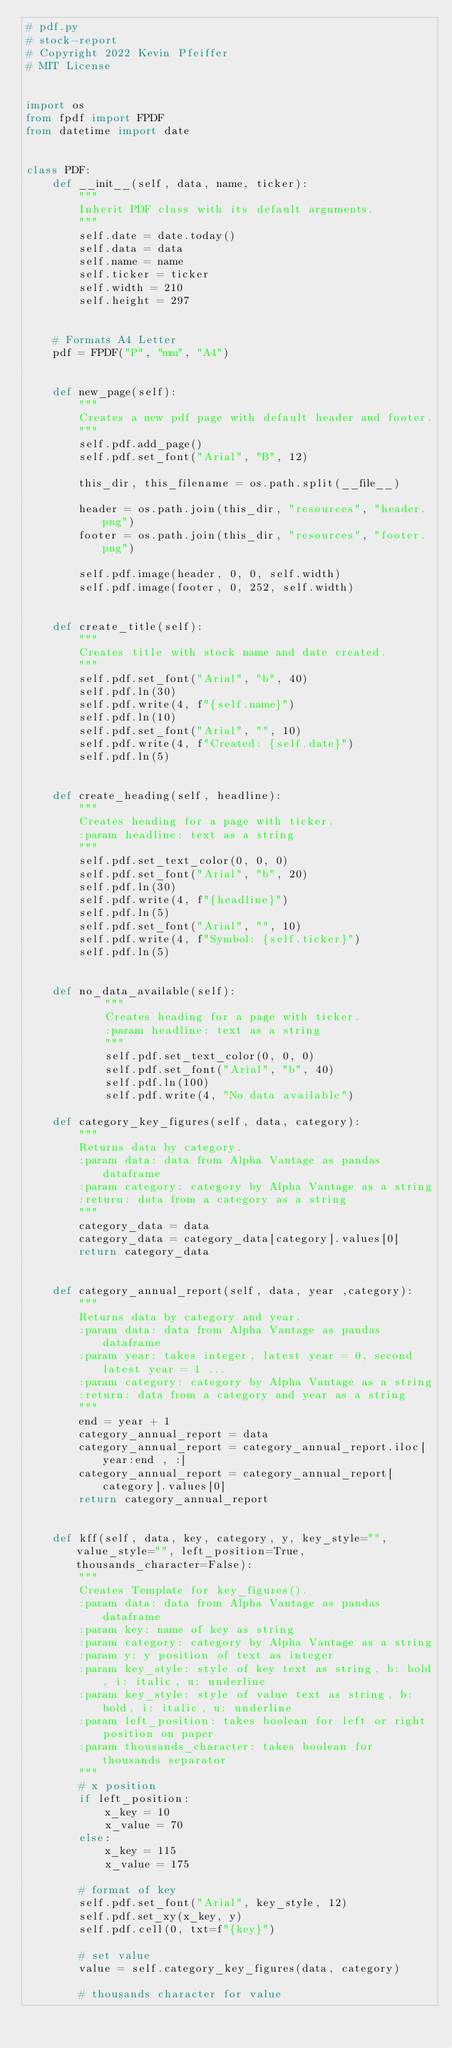Convert code to text. <code><loc_0><loc_0><loc_500><loc_500><_Python_># pdf.py
# stock-report
# Copyright 2022 Kevin Pfeiffer
# MIT License


import os
from fpdf import FPDF
from datetime import date


class PDF:
    def __init__(self, data, name, ticker):
        """
        Inherit PDF class with its default arguments.
        """
        self.date = date.today()
        self.data = data
        self.name = name
        self.ticker = ticker
        self.width = 210
        self.height = 297


    # Formats A4 Letter
    pdf = FPDF("P", "mm", "A4")


    def new_page(self):
        """
        Creates a new pdf page with default header and footer.
        """
        self.pdf.add_page()
        self.pdf.set_font("Arial", "B", 12)
        
        this_dir, this_filename = os.path.split(__file__)
        
        header = os.path.join(this_dir, "resources", "header.png")
        footer = os.path.join(this_dir, "resources", "footer.png")
        
        self.pdf.image(header, 0, 0, self.width)
        self.pdf.image(footer, 0, 252, self.width)


    def create_title(self):
        """
        Creates title with stock name and date created.
        """
        self.pdf.set_font("Arial", "b", 40)
        self.pdf.ln(30)
        self.pdf.write(4, f"{self.name}")
        self.pdf.ln(10)
        self.pdf.set_font("Arial", "", 10)
        self.pdf.write(4, f"Created: {self.date}")
        self.pdf.ln(5)
    
    
    def create_heading(self, headline):
        """
        Creates heading for a page with ticker.
        :param headline: text as a string
        """
        self.pdf.set_text_color(0, 0, 0)
        self.pdf.set_font("Arial", "b", 20)
        self.pdf.ln(30)
        self.pdf.write(4, f"{headline}")
        self.pdf.ln(5)
        self.pdf.set_font("Arial", "", 10)
        self.pdf.write(4, f"Symbol: {self.ticker}")
        self.pdf.ln(5)


    def no_data_available(self):
            """
            Creates heading for a page with ticker.
            :param headline: text as a string
            """
            self.pdf.set_text_color(0, 0, 0)
            self.pdf.set_font("Arial", "b", 40)
            self.pdf.ln(100)
            self.pdf.write(4, "No data available")

    def category_key_figures(self, data, category):
        """
        Returns data by category.
        :param data: data from Alpha Vantage as pandas dataframe
        :param category: category by Alpha Vantage as a string
        :return: data from a category as a string
        """
        category_data = data
        category_data = category_data[category].values[0]
        return category_data


    def category_annual_report(self, data, year ,category):
        """
        Returns data by category and year.
        :param data: data from Alpha Vantage as pandas dataframe
        :param year: takes integer, latest year = 0, second latest year = 1 ...
        :param category: category by Alpha Vantage as a string
        :return: data from a category and year as a string
        """
        end = year + 1
        category_annual_report = data
        category_annual_report = category_annual_report.iloc[year:end , :]
        category_annual_report = category_annual_report[category].values[0]
        return category_annual_report
    
    
    def kff(self, data, key, category, y, key_style="", value_style="", left_position=True, thousands_character=False):
        """
        Creates Template for key_figures().
        :param data: data from Alpha Vantage as pandas dataframe
        :param key: name of key as string
        :param category: category by Alpha Vantage as a string
        :param y: y position of text as integer
        :param key_style: style of key text as string, b: bold, i: italic, u: underline
        :param key_style: style of value text as string, b: bold, i: italic, u: underline
        :param left_position: takes boolean for left or right position on paper
        :param thousands_character: takes boolean for thousands separator
        """
        # x position
        if left_position:
            x_key = 10
            x_value = 70
        else:
            x_key = 115
            x_value = 175
        
        # format of key
        self.pdf.set_font("Arial", key_style, 12)
        self.pdf.set_xy(x_key, y)
        self.pdf.cell(0, txt=f"{key}")
        
        # set value
        value = self.category_key_figures(data, category)
        
        # thousands character for value</code> 